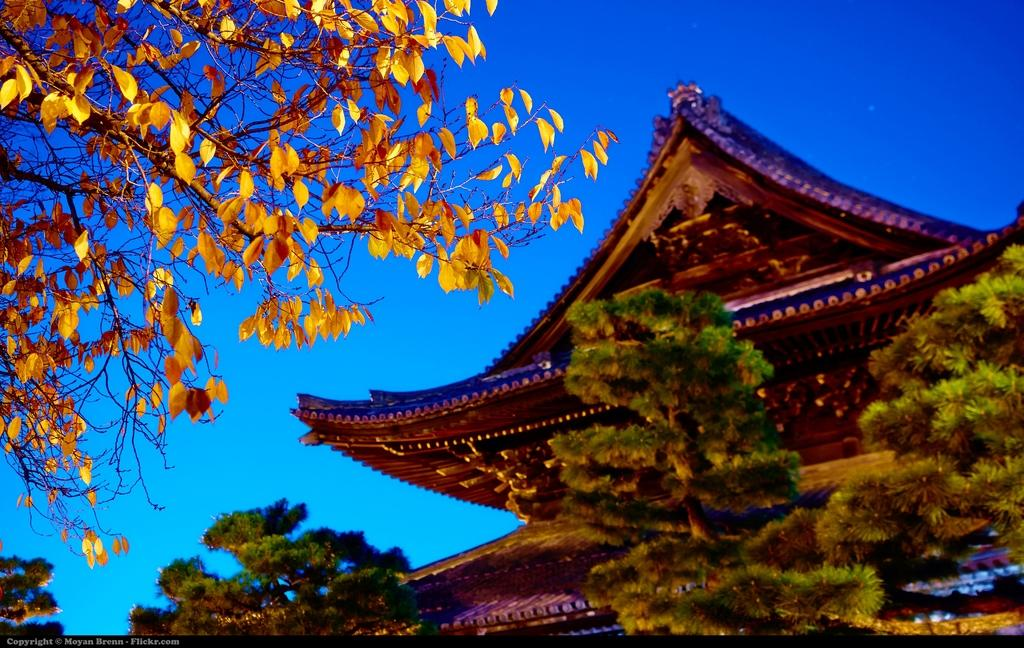What type of vegetation can be seen in the image? There are many trees in the image. What type of structure is visible in the image? There is a building to the side of the image. What color is the sky in the background of the image? The blue sky is visible in the background of the image. What type of guitar is being played in the image? There is no guitar present in the image; it features trees and a building. Can you tell me how many brains are visible in the image? There are no brains visible in the image; it features trees and a building. 